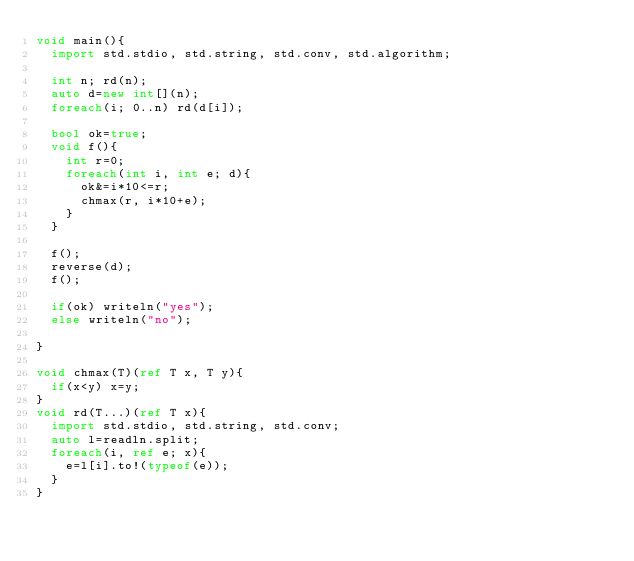Convert code to text. <code><loc_0><loc_0><loc_500><loc_500><_D_>void main(){
  import std.stdio, std.string, std.conv, std.algorithm;

  int n; rd(n);
  auto d=new int[](n);
  foreach(i; 0..n) rd(d[i]);

  bool ok=true;
  void f(){
    int r=0;
    foreach(int i, int e; d){
      ok&=i*10<=r;
      chmax(r, i*10+e);
    }
  }

  f();
  reverse(d);
  f();

  if(ok) writeln("yes");
  else writeln("no");
  
}

void chmax(T)(ref T x, T y){
  if(x<y) x=y;
}
void rd(T...)(ref T x){
  import std.stdio, std.string, std.conv;
  auto l=readln.split;
  foreach(i, ref e; x){
    e=l[i].to!(typeof(e));
  }
}</code> 